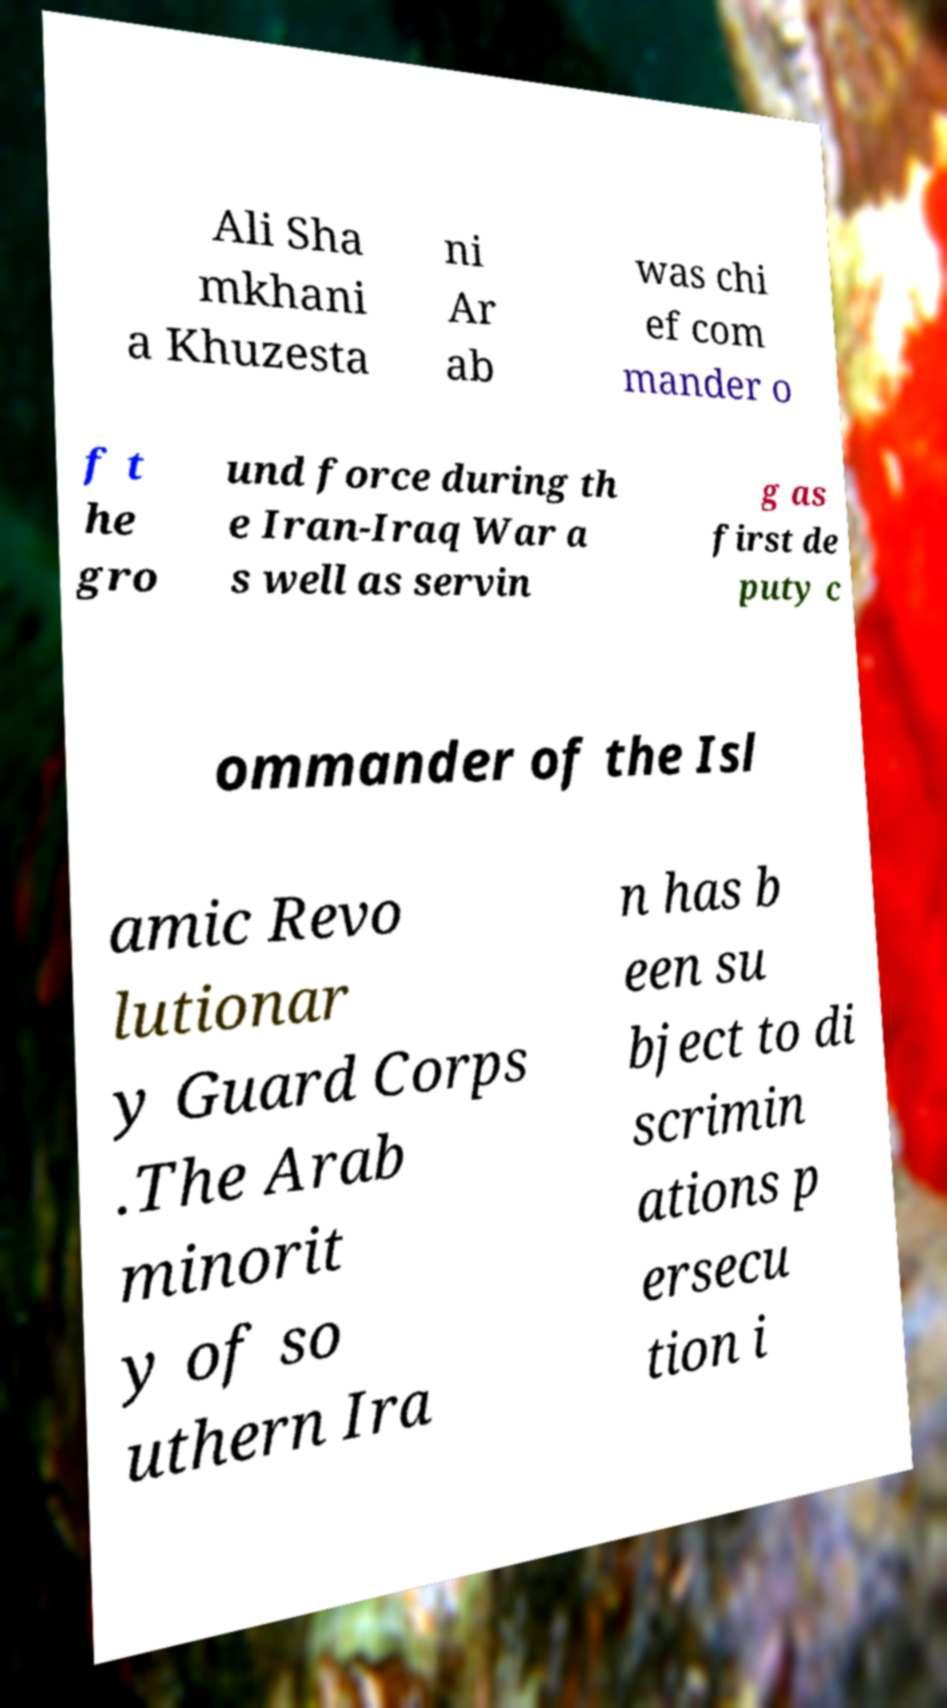Can you read and provide the text displayed in the image?This photo seems to have some interesting text. Can you extract and type it out for me? Ali Sha mkhani a Khuzesta ni Ar ab was chi ef com mander o f t he gro und force during th e Iran-Iraq War a s well as servin g as first de puty c ommander of the Isl amic Revo lutionar y Guard Corps .The Arab minorit y of so uthern Ira n has b een su bject to di scrimin ations p ersecu tion i 